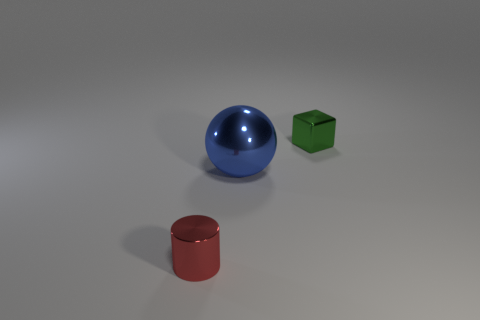Can you tell me the potential significance of having three different shapes in this image? The presence of three distinct geometric shapes—a sphere, a cube, and a cylinder—might represent diversity and variety. It suggests a visual contrast and creates a trio that can explore the concept of harmony despite differences. Additionally, the arrangement could be seen as a nod to classic geometric studies and may also invoke different associations, depending on the viewer's perspective. 